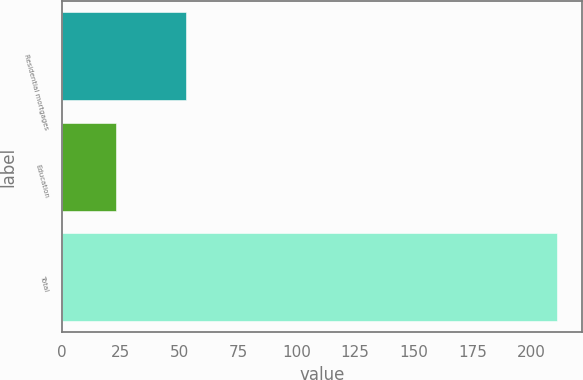Convert chart to OTSL. <chart><loc_0><loc_0><loc_500><loc_500><bar_chart><fcel>Residential mortgages<fcel>Education<fcel>Total<nl><fcel>53<fcel>23<fcel>211<nl></chart> 